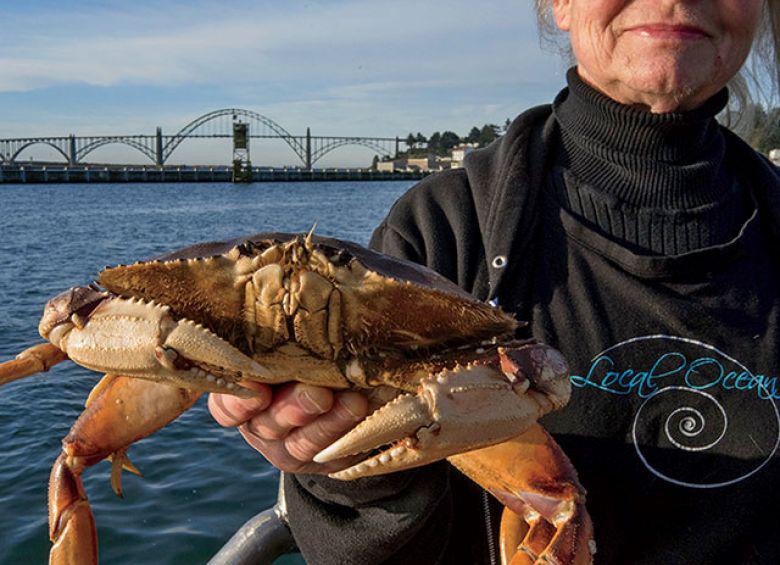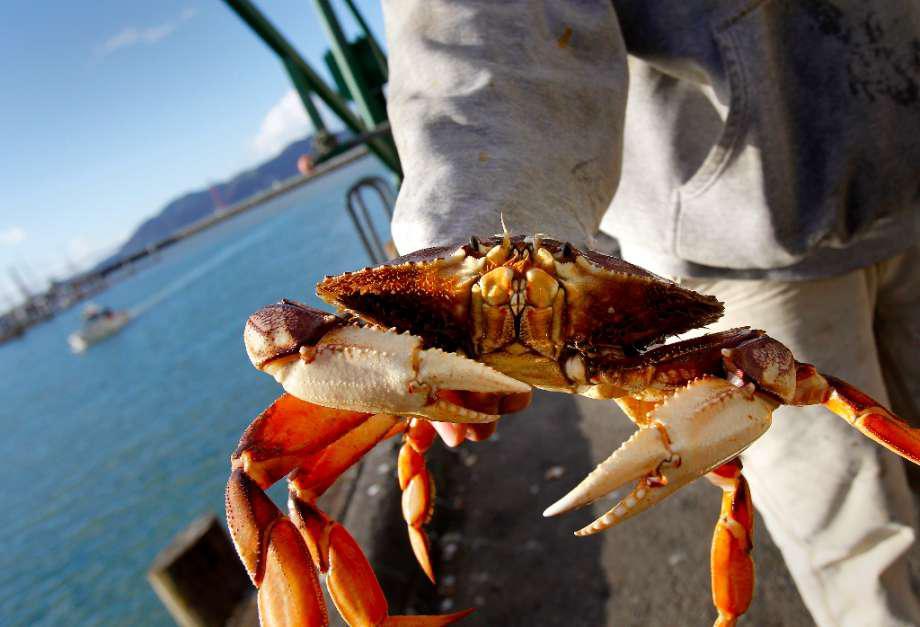The first image is the image on the left, the second image is the image on the right. Evaluate the accuracy of this statement regarding the images: "In every image, there is a human holding a crab.". Is it true? Answer yes or no. Yes. The first image is the image on the left, the second image is the image on the right. Assess this claim about the two images: "Each image includes a hand holding up a crab, and at least one image shows a bare hand, and at least one image shows the crab facing the camera.". Correct or not? Answer yes or no. Yes. 